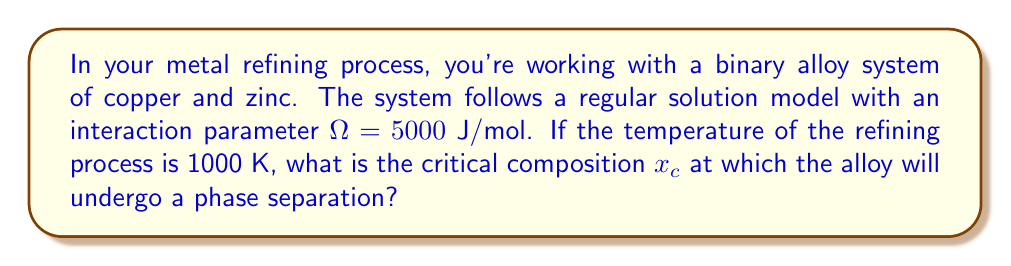Teach me how to tackle this problem. To solve this problem, we'll use the regular solution model and the concept of critical composition in binary alloys. The steps are as follows:

1) In a binary regular solution model, the critical composition $x_c$ is given by the equation:

   $$x_c = \frac{1}{2}$$

2) This is independent of the interaction parameter $\Omega$ and temperature $T$. However, we need to check if phase separation will occur at the given temperature.

3) The critical temperature $T_c$ for a regular solution is given by:

   $$T_c = \frac{\Omega}{2R}$$

   where $R$ is the gas constant (8.314 J/mol·K).

4) Let's calculate $T_c$:

   $$T_c = \frac{5000}{2 \cdot 8.314} = 300.7 \text{ K}$$

5) Since the given temperature (1000 K) is higher than $T_c$, the system is above its critical temperature. This means that at 1000 K, the alloy will form a homogeneous solution for all compositions, and no phase separation will occur.

6) However, if we were to cool the system below 300.7 K, phase separation would occur at the critical composition $x_c = 0.5$.
Answer: $x_c = 0.5$, but no phase separation at 1000 K 